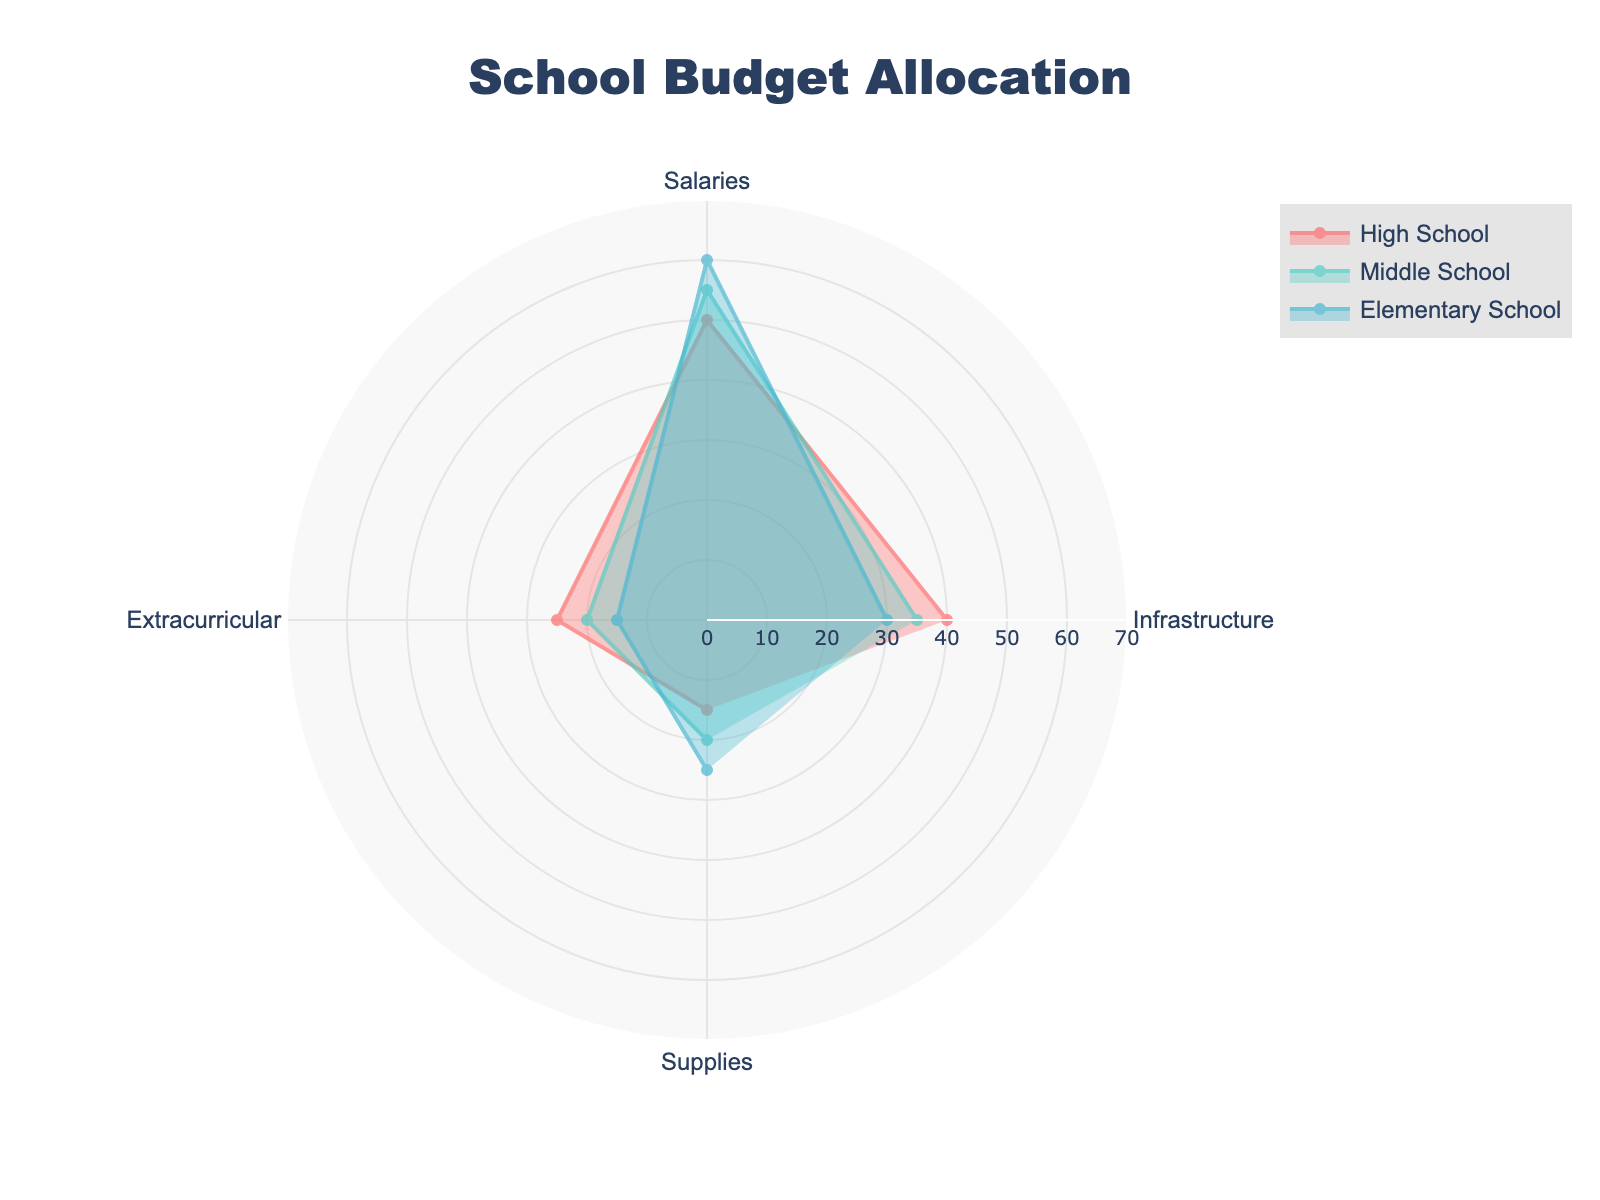what is the title of the figure? The title of the figure is located at the top center of the chart. It states the main subject of the figure.
Answer: School Budget Allocation How many categories are shown in the radar chart? Each axis of the radar chart corresponds to a category of school budget allocation. Count the axes to determine the number of categories.
Answer: 4 What is the category with the highest allocation for Elementary School? Look for the highest point in the Elementary School data trace. Observe the axis label corresponding to this point.
Answer: Salaries Which school has the highest allocation in the Extracurricular category? Locate the Extracurricular axis, then compare the data points for each school to see which is the highest.
Answer: High School Which category has the smallest variation in allocation across all schools? To find the category with the smallest variation, observe which axis has the closest data points for all three schools.
Answer: Extracurricular What is the sum of allocations for Supplies in all schools? To compute the sum, add up the values for the Supplies category for each school: 15 (High School) + 20 (Middle School) + 25 (Elementary School).
Answer: 60 Compare the allocations for Infrastructure and Supplies in High School. Which is greater? Look at the points on the radar chart for Infrastructure and Supplies in High School and compare their values.
Answer: Infrastructure What is the average allocation for Salaries across all schools? Add the Salaries values for each school (50 + 55 + 60) and divide by 3 (the number of schools).
Answer: 55 Which school has the lowest overall budget allocation in Extracurricular? Find the data point on the Extracurricular axis for each school and determine the smallest value.
Answer: Elementary School By how much does the Middle School allocation for Infrastructure differ from the High School allocation for the same category? Subtract the value of Infrastructure for Middle School from High School: 40 (High School) - 35 (Middle School).
Answer: 5 